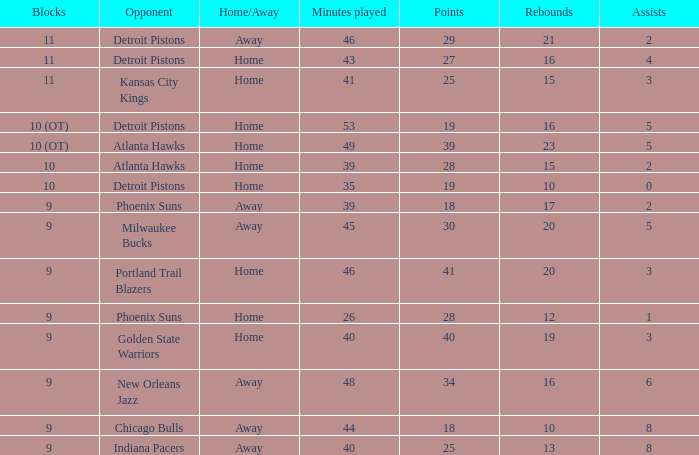I'm looking to parse the entire table for insights. Could you assist me with that? {'header': ['Blocks', 'Opponent', 'Home/Away', 'Minutes played', 'Points', 'Rebounds', 'Assists'], 'rows': [['11', 'Detroit Pistons', 'Away', '46', '29', '21', '2'], ['11', 'Detroit Pistons', 'Home', '43', '27', '16', '4'], ['11', 'Kansas City Kings', 'Home', '41', '25', '15', '3'], ['10 (OT)', 'Detroit Pistons', 'Home', '53', '19', '16', '5'], ['10 (OT)', 'Atlanta Hawks', 'Home', '49', '39', '23', '5'], ['10', 'Atlanta Hawks', 'Home', '39', '28', '15', '2'], ['10', 'Detroit Pistons', 'Home', '35', '19', '10', '0'], ['9', 'Phoenix Suns', 'Away', '39', '18', '17', '2'], ['9', 'Milwaukee Bucks', 'Away', '45', '30', '20', '5'], ['9', 'Portland Trail Blazers', 'Home', '46', '41', '20', '3'], ['9', 'Phoenix Suns', 'Home', '26', '28', '12', '1'], ['9', 'Golden State Warriors', 'Home', '40', '40', '19', '3'], ['9', 'New Orleans Jazz', 'Away', '48', '34', '16', '6'], ['9', 'Chicago Bulls', 'Away', '44', '18', '10', '8'], ['9', 'Indiana Pacers', 'Away', '40', '25', '13', '8']]} How many minutes were played when there were 18 points and the opponent was Chicago Bulls? 1.0. 